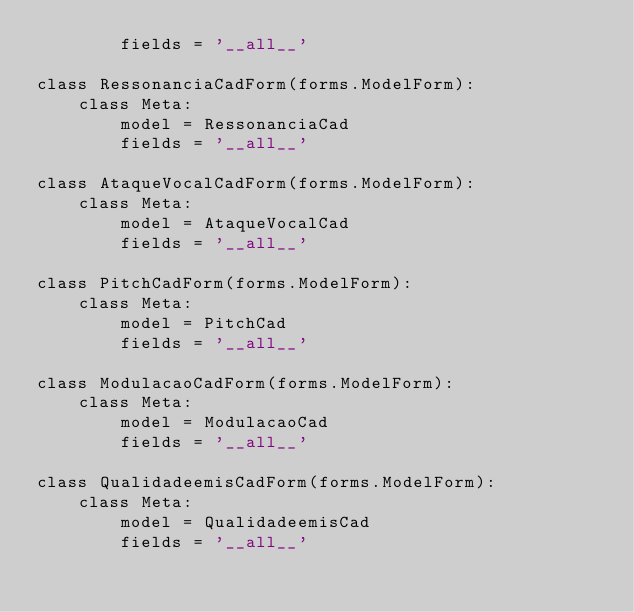<code> <loc_0><loc_0><loc_500><loc_500><_Python_>        fields = '__all__'        
        
class RessonanciaCadForm(forms.ModelForm):
    class Meta:
        model = RessonanciaCad
        fields = '__all__'

class AtaqueVocalCadForm(forms.ModelForm):
    class Meta:
        model = AtaqueVocalCad
        fields = '__all__'        

class PitchCadForm(forms.ModelForm):
    class Meta:
        model = PitchCad
        fields = '__all__'        
        
class ModulacaoCadForm(forms.ModelForm):
    class Meta:
        model = ModulacaoCad
        fields = '__all__'        
        
class QualidadeemisCadForm(forms.ModelForm):
    class Meta:
        model = QualidadeemisCad
        fields = '__all__'
            </code> 